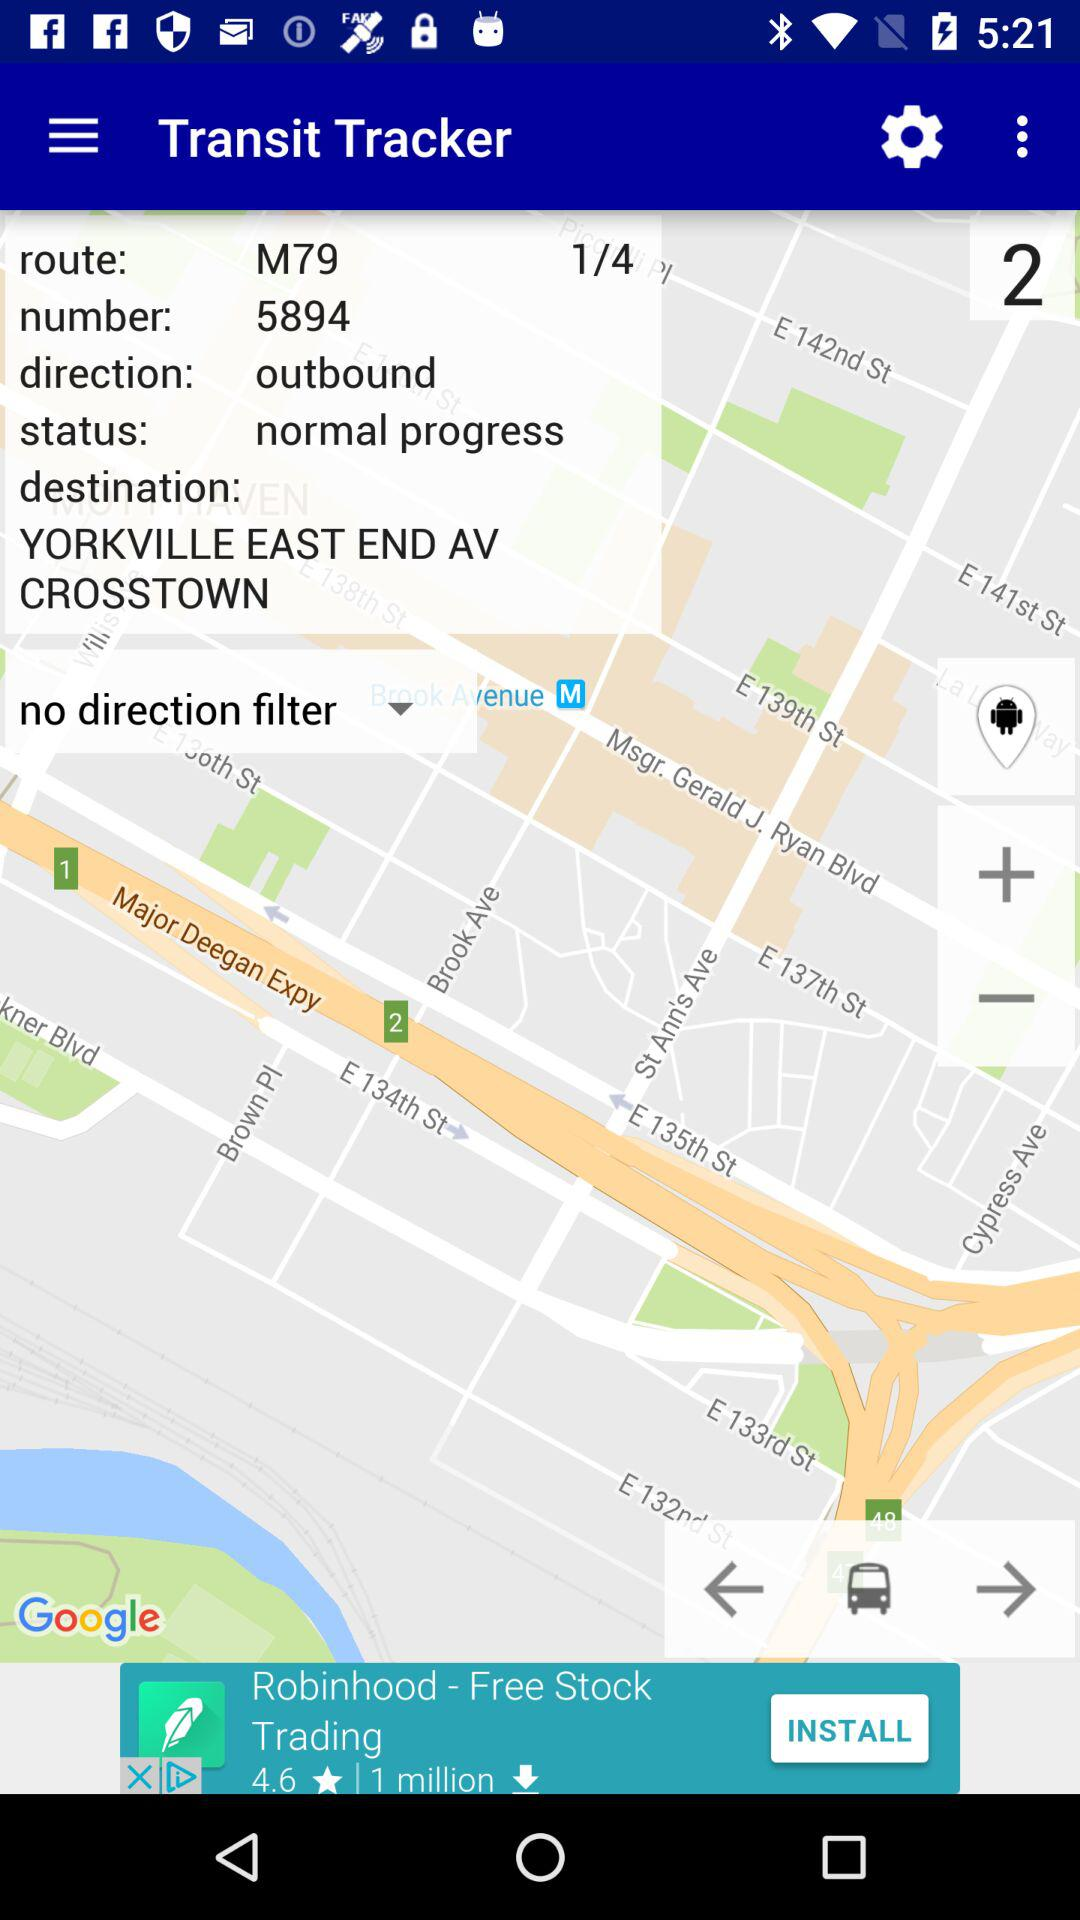What is the route number? The route number is M79. 